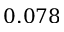Convert formula to latex. <formula><loc_0><loc_0><loc_500><loc_500>0 . 0 7 8</formula> 